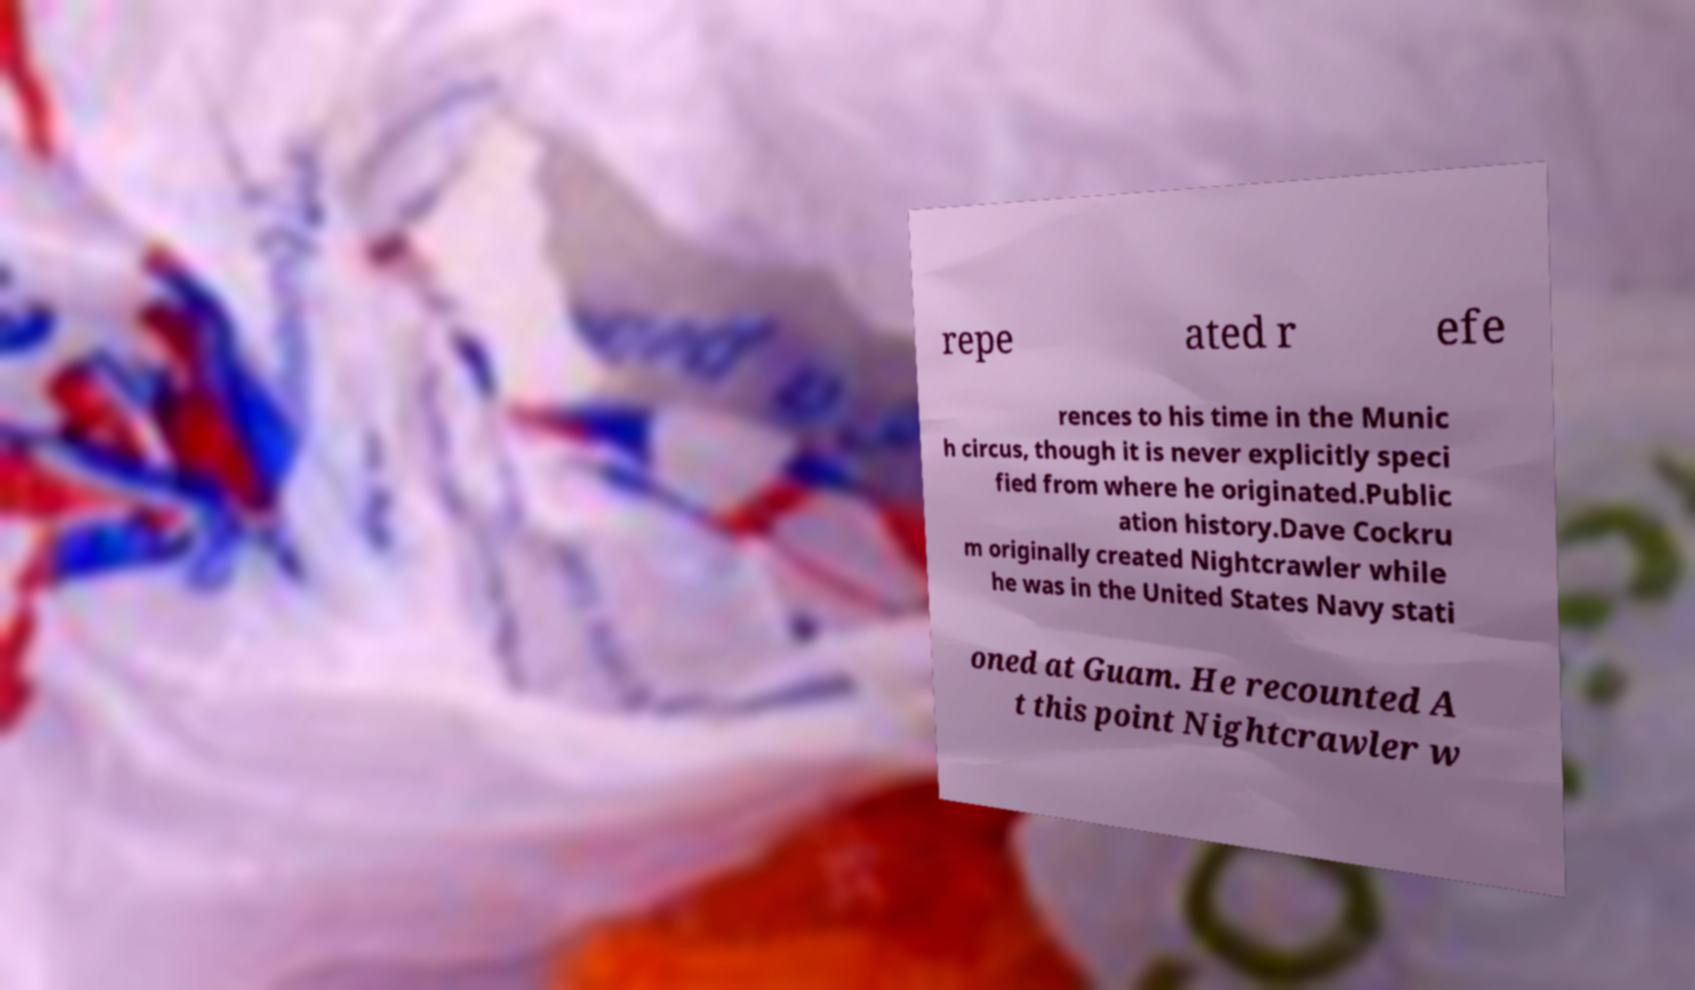Can you read and provide the text displayed in the image?This photo seems to have some interesting text. Can you extract and type it out for me? repe ated r efe rences to his time in the Munic h circus, though it is never explicitly speci fied from where he originated.Public ation history.Dave Cockru m originally created Nightcrawler while he was in the United States Navy stati oned at Guam. He recounted A t this point Nightcrawler w 